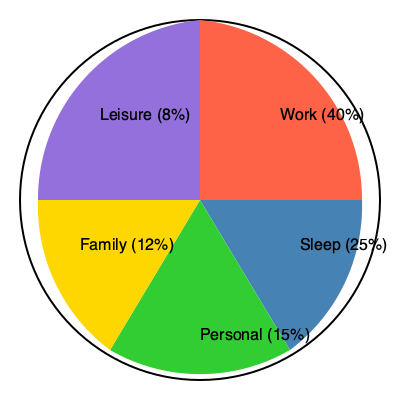As a freelancer managing multiple clients, you've created a pie chart to visualize your ideal time allocation for work-life balance. If you work an average of 9.6 hours per day, how many hours per week do you dedicate to personal activities? To solve this problem, we'll follow these steps:

1. Identify the percentage allocated to personal activities from the pie chart: 15%

2. Calculate the total hours in a day:
   Since work takes 40% of the day and equals 9.6 hours,
   $\frac{9.6}{0.40} = 24$ hours in a day

3. Calculate the hours per day for personal activities:
   $24 \text{ hours} \times 0.15 = 3.6 \text{ hours per day}$

4. Convert daily hours to weekly hours:
   $3.6 \text{ hours/day} \times 7 \text{ days/week} = 25.2 \text{ hours per week}$

Therefore, based on the pie chart and given information, you dedicate 25.2 hours per week to personal activities.
Answer: 25.2 hours 